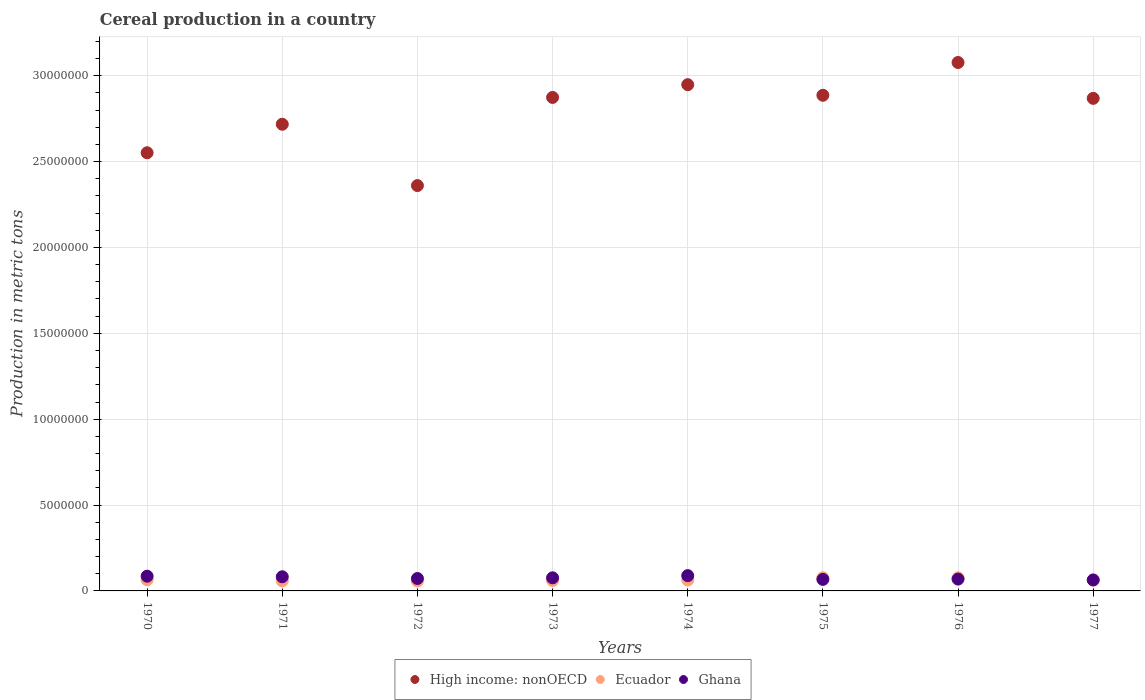What is the total cereal production in Ghana in 1976?
Keep it short and to the point. 6.89e+05. Across all years, what is the maximum total cereal production in High income: nonOECD?
Your response must be concise. 3.08e+07. Across all years, what is the minimum total cereal production in Ecuador?
Keep it short and to the point. 5.77e+05. In which year was the total cereal production in Ghana maximum?
Provide a succinct answer. 1974. What is the total total cereal production in High income: nonOECD in the graph?
Your response must be concise. 2.23e+08. What is the difference between the total cereal production in Ghana in 1971 and that in 1973?
Make the answer very short. 5.90e+04. What is the difference between the total cereal production in Ghana in 1973 and the total cereal production in Ecuador in 1976?
Give a very brief answer. 77. What is the average total cereal production in Ecuador per year?
Your answer should be compact. 6.53e+05. In the year 1975, what is the difference between the total cereal production in High income: nonOECD and total cereal production in Ecuador?
Provide a succinct answer. 2.81e+07. In how many years, is the total cereal production in Ecuador greater than 12000000 metric tons?
Make the answer very short. 0. What is the ratio of the total cereal production in Ecuador in 1972 to that in 1977?
Offer a terse response. 0.92. Is the total cereal production in High income: nonOECD in 1974 less than that in 1976?
Make the answer very short. Yes. What is the difference between the highest and the second highest total cereal production in High income: nonOECD?
Provide a succinct answer. 1.29e+06. What is the difference between the highest and the lowest total cereal production in High income: nonOECD?
Your response must be concise. 7.17e+06. In how many years, is the total cereal production in Ghana greater than the average total cereal production in Ghana taken over all years?
Offer a terse response. 4. Is the sum of the total cereal production in Ghana in 1970 and 1976 greater than the maximum total cereal production in High income: nonOECD across all years?
Your answer should be compact. No. Is the total cereal production in Ghana strictly greater than the total cereal production in High income: nonOECD over the years?
Make the answer very short. No. Are the values on the major ticks of Y-axis written in scientific E-notation?
Your response must be concise. No. Does the graph contain any zero values?
Your answer should be compact. No. Does the graph contain grids?
Offer a very short reply. Yes. Where does the legend appear in the graph?
Offer a terse response. Bottom center. How many legend labels are there?
Offer a very short reply. 3. What is the title of the graph?
Your answer should be very brief. Cereal production in a country. Does "Malawi" appear as one of the legend labels in the graph?
Provide a succinct answer. No. What is the label or title of the Y-axis?
Your response must be concise. Production in metric tons. What is the Production in metric tons of High income: nonOECD in 1970?
Your answer should be very brief. 2.55e+07. What is the Production in metric tons of Ecuador in 1970?
Provide a short and direct response. 6.51e+05. What is the Production in metric tons of Ghana in 1970?
Offer a terse response. 8.58e+05. What is the Production in metric tons in High income: nonOECD in 1971?
Offer a very short reply. 2.72e+07. What is the Production in metric tons in Ecuador in 1971?
Offer a terse response. 5.89e+05. What is the Production in metric tons in Ghana in 1971?
Give a very brief answer. 8.23e+05. What is the Production in metric tons of High income: nonOECD in 1972?
Offer a very short reply. 2.36e+07. What is the Production in metric tons of Ecuador in 1972?
Give a very brief answer. 5.77e+05. What is the Production in metric tons in Ghana in 1972?
Make the answer very short. 7.24e+05. What is the Production in metric tons of High income: nonOECD in 1973?
Your answer should be compact. 2.87e+07. What is the Production in metric tons in Ecuador in 1973?
Provide a succinct answer. 6.08e+05. What is the Production in metric tons in Ghana in 1973?
Make the answer very short. 7.64e+05. What is the Production in metric tons in High income: nonOECD in 1974?
Your response must be concise. 2.95e+07. What is the Production in metric tons of Ecuador in 1974?
Provide a succinct answer. 6.36e+05. What is the Production in metric tons of Ghana in 1974?
Offer a terse response. 8.90e+05. What is the Production in metric tons in High income: nonOECD in 1975?
Your answer should be very brief. 2.89e+07. What is the Production in metric tons of Ecuador in 1975?
Provide a short and direct response. 7.67e+05. What is the Production in metric tons in Ghana in 1975?
Your answer should be compact. 6.72e+05. What is the Production in metric tons in High income: nonOECD in 1976?
Your response must be concise. 3.08e+07. What is the Production in metric tons in Ecuador in 1976?
Keep it short and to the point. 7.64e+05. What is the Production in metric tons of Ghana in 1976?
Make the answer very short. 6.89e+05. What is the Production in metric tons in High income: nonOECD in 1977?
Provide a short and direct response. 2.87e+07. What is the Production in metric tons in Ecuador in 1977?
Keep it short and to the point. 6.31e+05. What is the Production in metric tons in Ghana in 1977?
Make the answer very short. 6.39e+05. Across all years, what is the maximum Production in metric tons of High income: nonOECD?
Your answer should be very brief. 3.08e+07. Across all years, what is the maximum Production in metric tons in Ecuador?
Give a very brief answer. 7.67e+05. Across all years, what is the maximum Production in metric tons of Ghana?
Provide a succinct answer. 8.90e+05. Across all years, what is the minimum Production in metric tons of High income: nonOECD?
Your response must be concise. 2.36e+07. Across all years, what is the minimum Production in metric tons in Ecuador?
Make the answer very short. 5.77e+05. Across all years, what is the minimum Production in metric tons in Ghana?
Make the answer very short. 6.39e+05. What is the total Production in metric tons in High income: nonOECD in the graph?
Keep it short and to the point. 2.23e+08. What is the total Production in metric tons of Ecuador in the graph?
Make the answer very short. 5.22e+06. What is the total Production in metric tons of Ghana in the graph?
Make the answer very short. 6.06e+06. What is the difference between the Production in metric tons of High income: nonOECD in 1970 and that in 1971?
Offer a very short reply. -1.66e+06. What is the difference between the Production in metric tons in Ecuador in 1970 and that in 1971?
Your answer should be very brief. 6.20e+04. What is the difference between the Production in metric tons in Ghana in 1970 and that in 1971?
Keep it short and to the point. 3.44e+04. What is the difference between the Production in metric tons of High income: nonOECD in 1970 and that in 1972?
Keep it short and to the point. 1.91e+06. What is the difference between the Production in metric tons of Ecuador in 1970 and that in 1972?
Ensure brevity in your answer.  7.34e+04. What is the difference between the Production in metric tons in Ghana in 1970 and that in 1972?
Keep it short and to the point. 1.34e+05. What is the difference between the Production in metric tons in High income: nonOECD in 1970 and that in 1973?
Offer a terse response. -3.22e+06. What is the difference between the Production in metric tons in Ecuador in 1970 and that in 1973?
Give a very brief answer. 4.26e+04. What is the difference between the Production in metric tons of Ghana in 1970 and that in 1973?
Give a very brief answer. 9.34e+04. What is the difference between the Production in metric tons in High income: nonOECD in 1970 and that in 1974?
Your answer should be very brief. -3.96e+06. What is the difference between the Production in metric tons in Ecuador in 1970 and that in 1974?
Your answer should be very brief. 1.49e+04. What is the difference between the Production in metric tons in Ghana in 1970 and that in 1974?
Your response must be concise. -3.26e+04. What is the difference between the Production in metric tons in High income: nonOECD in 1970 and that in 1975?
Make the answer very short. -3.35e+06. What is the difference between the Production in metric tons in Ecuador in 1970 and that in 1975?
Keep it short and to the point. -1.16e+05. What is the difference between the Production in metric tons in Ghana in 1970 and that in 1975?
Ensure brevity in your answer.  1.86e+05. What is the difference between the Production in metric tons in High income: nonOECD in 1970 and that in 1976?
Give a very brief answer. -5.26e+06. What is the difference between the Production in metric tons of Ecuador in 1970 and that in 1976?
Your answer should be compact. -1.13e+05. What is the difference between the Production in metric tons of Ghana in 1970 and that in 1976?
Ensure brevity in your answer.  1.69e+05. What is the difference between the Production in metric tons of High income: nonOECD in 1970 and that in 1977?
Your answer should be compact. -3.17e+06. What is the difference between the Production in metric tons in Ecuador in 1970 and that in 1977?
Keep it short and to the point. 1.98e+04. What is the difference between the Production in metric tons of Ghana in 1970 and that in 1977?
Your answer should be very brief. 2.18e+05. What is the difference between the Production in metric tons in High income: nonOECD in 1971 and that in 1972?
Provide a short and direct response. 3.57e+06. What is the difference between the Production in metric tons of Ecuador in 1971 and that in 1972?
Make the answer very short. 1.13e+04. What is the difference between the Production in metric tons in Ghana in 1971 and that in 1972?
Keep it short and to the point. 9.96e+04. What is the difference between the Production in metric tons of High income: nonOECD in 1971 and that in 1973?
Keep it short and to the point. -1.56e+06. What is the difference between the Production in metric tons in Ecuador in 1971 and that in 1973?
Ensure brevity in your answer.  -1.94e+04. What is the difference between the Production in metric tons in Ghana in 1971 and that in 1973?
Offer a terse response. 5.90e+04. What is the difference between the Production in metric tons of High income: nonOECD in 1971 and that in 1974?
Your response must be concise. -2.30e+06. What is the difference between the Production in metric tons of Ecuador in 1971 and that in 1974?
Your answer should be very brief. -4.71e+04. What is the difference between the Production in metric tons of Ghana in 1971 and that in 1974?
Keep it short and to the point. -6.70e+04. What is the difference between the Production in metric tons in High income: nonOECD in 1971 and that in 1975?
Your response must be concise. -1.69e+06. What is the difference between the Production in metric tons of Ecuador in 1971 and that in 1975?
Your answer should be compact. -1.78e+05. What is the difference between the Production in metric tons of Ghana in 1971 and that in 1975?
Your response must be concise. 1.52e+05. What is the difference between the Production in metric tons in High income: nonOECD in 1971 and that in 1976?
Provide a short and direct response. -3.60e+06. What is the difference between the Production in metric tons in Ecuador in 1971 and that in 1976?
Your answer should be very brief. -1.75e+05. What is the difference between the Production in metric tons of Ghana in 1971 and that in 1976?
Offer a very short reply. 1.34e+05. What is the difference between the Production in metric tons in High income: nonOECD in 1971 and that in 1977?
Offer a terse response. -1.51e+06. What is the difference between the Production in metric tons of Ecuador in 1971 and that in 1977?
Give a very brief answer. -4.22e+04. What is the difference between the Production in metric tons in Ghana in 1971 and that in 1977?
Offer a terse response. 1.84e+05. What is the difference between the Production in metric tons of High income: nonOECD in 1972 and that in 1973?
Keep it short and to the point. -5.13e+06. What is the difference between the Production in metric tons in Ecuador in 1972 and that in 1973?
Provide a succinct answer. -3.07e+04. What is the difference between the Production in metric tons of Ghana in 1972 and that in 1973?
Ensure brevity in your answer.  -4.06e+04. What is the difference between the Production in metric tons of High income: nonOECD in 1972 and that in 1974?
Your answer should be very brief. -5.87e+06. What is the difference between the Production in metric tons of Ecuador in 1972 and that in 1974?
Your response must be concise. -5.84e+04. What is the difference between the Production in metric tons of Ghana in 1972 and that in 1974?
Your answer should be very brief. -1.67e+05. What is the difference between the Production in metric tons of High income: nonOECD in 1972 and that in 1975?
Your answer should be compact. -5.26e+06. What is the difference between the Production in metric tons of Ecuador in 1972 and that in 1975?
Provide a short and direct response. -1.90e+05. What is the difference between the Production in metric tons in Ghana in 1972 and that in 1975?
Your response must be concise. 5.20e+04. What is the difference between the Production in metric tons of High income: nonOECD in 1972 and that in 1976?
Keep it short and to the point. -7.17e+06. What is the difference between the Production in metric tons in Ecuador in 1972 and that in 1976?
Make the answer very short. -1.87e+05. What is the difference between the Production in metric tons of Ghana in 1972 and that in 1976?
Give a very brief answer. 3.47e+04. What is the difference between the Production in metric tons in High income: nonOECD in 1972 and that in 1977?
Your answer should be compact. -5.08e+06. What is the difference between the Production in metric tons in Ecuador in 1972 and that in 1977?
Your answer should be compact. -5.35e+04. What is the difference between the Production in metric tons of Ghana in 1972 and that in 1977?
Ensure brevity in your answer.  8.45e+04. What is the difference between the Production in metric tons in High income: nonOECD in 1973 and that in 1974?
Your answer should be compact. -7.43e+05. What is the difference between the Production in metric tons in Ecuador in 1973 and that in 1974?
Provide a succinct answer. -2.77e+04. What is the difference between the Production in metric tons in Ghana in 1973 and that in 1974?
Your answer should be compact. -1.26e+05. What is the difference between the Production in metric tons in High income: nonOECD in 1973 and that in 1975?
Your answer should be very brief. -1.25e+05. What is the difference between the Production in metric tons in Ecuador in 1973 and that in 1975?
Provide a succinct answer. -1.59e+05. What is the difference between the Production in metric tons in Ghana in 1973 and that in 1975?
Provide a short and direct response. 9.26e+04. What is the difference between the Production in metric tons in High income: nonOECD in 1973 and that in 1976?
Ensure brevity in your answer.  -2.03e+06. What is the difference between the Production in metric tons in Ecuador in 1973 and that in 1976?
Ensure brevity in your answer.  -1.56e+05. What is the difference between the Production in metric tons in Ghana in 1973 and that in 1976?
Give a very brief answer. 7.53e+04. What is the difference between the Production in metric tons of High income: nonOECD in 1973 and that in 1977?
Keep it short and to the point. 5.30e+04. What is the difference between the Production in metric tons in Ecuador in 1973 and that in 1977?
Provide a succinct answer. -2.28e+04. What is the difference between the Production in metric tons of Ghana in 1973 and that in 1977?
Offer a terse response. 1.25e+05. What is the difference between the Production in metric tons of High income: nonOECD in 1974 and that in 1975?
Ensure brevity in your answer.  6.17e+05. What is the difference between the Production in metric tons in Ecuador in 1974 and that in 1975?
Your answer should be very brief. -1.31e+05. What is the difference between the Production in metric tons in Ghana in 1974 and that in 1975?
Provide a succinct answer. 2.19e+05. What is the difference between the Production in metric tons in High income: nonOECD in 1974 and that in 1976?
Provide a succinct answer. -1.29e+06. What is the difference between the Production in metric tons in Ecuador in 1974 and that in 1976?
Give a very brief answer. -1.28e+05. What is the difference between the Production in metric tons in Ghana in 1974 and that in 1976?
Offer a very short reply. 2.01e+05. What is the difference between the Production in metric tons of High income: nonOECD in 1974 and that in 1977?
Make the answer very short. 7.96e+05. What is the difference between the Production in metric tons of Ecuador in 1974 and that in 1977?
Keep it short and to the point. 4899. What is the difference between the Production in metric tons in Ghana in 1974 and that in 1977?
Offer a terse response. 2.51e+05. What is the difference between the Production in metric tons of High income: nonOECD in 1975 and that in 1976?
Offer a terse response. -1.91e+06. What is the difference between the Production in metric tons of Ecuador in 1975 and that in 1976?
Your answer should be very brief. 2927. What is the difference between the Production in metric tons of Ghana in 1975 and that in 1976?
Your response must be concise. -1.73e+04. What is the difference between the Production in metric tons in High income: nonOECD in 1975 and that in 1977?
Your response must be concise. 1.78e+05. What is the difference between the Production in metric tons of Ecuador in 1975 and that in 1977?
Provide a succinct answer. 1.36e+05. What is the difference between the Production in metric tons of Ghana in 1975 and that in 1977?
Your answer should be compact. 3.25e+04. What is the difference between the Production in metric tons of High income: nonOECD in 1976 and that in 1977?
Make the answer very short. 2.09e+06. What is the difference between the Production in metric tons in Ecuador in 1976 and that in 1977?
Your response must be concise. 1.33e+05. What is the difference between the Production in metric tons of Ghana in 1976 and that in 1977?
Make the answer very short. 4.98e+04. What is the difference between the Production in metric tons of High income: nonOECD in 1970 and the Production in metric tons of Ecuador in 1971?
Keep it short and to the point. 2.49e+07. What is the difference between the Production in metric tons of High income: nonOECD in 1970 and the Production in metric tons of Ghana in 1971?
Keep it short and to the point. 2.47e+07. What is the difference between the Production in metric tons in Ecuador in 1970 and the Production in metric tons in Ghana in 1971?
Keep it short and to the point. -1.72e+05. What is the difference between the Production in metric tons of High income: nonOECD in 1970 and the Production in metric tons of Ecuador in 1972?
Ensure brevity in your answer.  2.49e+07. What is the difference between the Production in metric tons of High income: nonOECD in 1970 and the Production in metric tons of Ghana in 1972?
Your response must be concise. 2.48e+07. What is the difference between the Production in metric tons of Ecuador in 1970 and the Production in metric tons of Ghana in 1972?
Offer a very short reply. -7.27e+04. What is the difference between the Production in metric tons of High income: nonOECD in 1970 and the Production in metric tons of Ecuador in 1973?
Provide a short and direct response. 2.49e+07. What is the difference between the Production in metric tons of High income: nonOECD in 1970 and the Production in metric tons of Ghana in 1973?
Offer a terse response. 2.47e+07. What is the difference between the Production in metric tons in Ecuador in 1970 and the Production in metric tons in Ghana in 1973?
Offer a very short reply. -1.13e+05. What is the difference between the Production in metric tons in High income: nonOECD in 1970 and the Production in metric tons in Ecuador in 1974?
Your answer should be compact. 2.49e+07. What is the difference between the Production in metric tons in High income: nonOECD in 1970 and the Production in metric tons in Ghana in 1974?
Your response must be concise. 2.46e+07. What is the difference between the Production in metric tons of Ecuador in 1970 and the Production in metric tons of Ghana in 1974?
Your answer should be very brief. -2.39e+05. What is the difference between the Production in metric tons in High income: nonOECD in 1970 and the Production in metric tons in Ecuador in 1975?
Give a very brief answer. 2.47e+07. What is the difference between the Production in metric tons in High income: nonOECD in 1970 and the Production in metric tons in Ghana in 1975?
Your answer should be compact. 2.48e+07. What is the difference between the Production in metric tons in Ecuador in 1970 and the Production in metric tons in Ghana in 1975?
Keep it short and to the point. -2.07e+04. What is the difference between the Production in metric tons in High income: nonOECD in 1970 and the Production in metric tons in Ecuador in 1976?
Your answer should be compact. 2.47e+07. What is the difference between the Production in metric tons in High income: nonOECD in 1970 and the Production in metric tons in Ghana in 1976?
Offer a terse response. 2.48e+07. What is the difference between the Production in metric tons of Ecuador in 1970 and the Production in metric tons of Ghana in 1976?
Offer a very short reply. -3.80e+04. What is the difference between the Production in metric tons of High income: nonOECD in 1970 and the Production in metric tons of Ecuador in 1977?
Your response must be concise. 2.49e+07. What is the difference between the Production in metric tons of High income: nonOECD in 1970 and the Production in metric tons of Ghana in 1977?
Your response must be concise. 2.49e+07. What is the difference between the Production in metric tons in Ecuador in 1970 and the Production in metric tons in Ghana in 1977?
Keep it short and to the point. 1.18e+04. What is the difference between the Production in metric tons of High income: nonOECD in 1971 and the Production in metric tons of Ecuador in 1972?
Make the answer very short. 2.66e+07. What is the difference between the Production in metric tons of High income: nonOECD in 1971 and the Production in metric tons of Ghana in 1972?
Give a very brief answer. 2.65e+07. What is the difference between the Production in metric tons in Ecuador in 1971 and the Production in metric tons in Ghana in 1972?
Give a very brief answer. -1.35e+05. What is the difference between the Production in metric tons of High income: nonOECD in 1971 and the Production in metric tons of Ecuador in 1973?
Ensure brevity in your answer.  2.66e+07. What is the difference between the Production in metric tons of High income: nonOECD in 1971 and the Production in metric tons of Ghana in 1973?
Provide a succinct answer. 2.64e+07. What is the difference between the Production in metric tons of Ecuador in 1971 and the Production in metric tons of Ghana in 1973?
Keep it short and to the point. -1.75e+05. What is the difference between the Production in metric tons in High income: nonOECD in 1971 and the Production in metric tons in Ecuador in 1974?
Offer a very short reply. 2.65e+07. What is the difference between the Production in metric tons of High income: nonOECD in 1971 and the Production in metric tons of Ghana in 1974?
Keep it short and to the point. 2.63e+07. What is the difference between the Production in metric tons of Ecuador in 1971 and the Production in metric tons of Ghana in 1974?
Offer a very short reply. -3.01e+05. What is the difference between the Production in metric tons in High income: nonOECD in 1971 and the Production in metric tons in Ecuador in 1975?
Ensure brevity in your answer.  2.64e+07. What is the difference between the Production in metric tons of High income: nonOECD in 1971 and the Production in metric tons of Ghana in 1975?
Provide a succinct answer. 2.65e+07. What is the difference between the Production in metric tons of Ecuador in 1971 and the Production in metric tons of Ghana in 1975?
Your answer should be very brief. -8.27e+04. What is the difference between the Production in metric tons of High income: nonOECD in 1971 and the Production in metric tons of Ecuador in 1976?
Provide a short and direct response. 2.64e+07. What is the difference between the Production in metric tons of High income: nonOECD in 1971 and the Production in metric tons of Ghana in 1976?
Your answer should be compact. 2.65e+07. What is the difference between the Production in metric tons in Ecuador in 1971 and the Production in metric tons in Ghana in 1976?
Keep it short and to the point. -1.00e+05. What is the difference between the Production in metric tons in High income: nonOECD in 1971 and the Production in metric tons in Ecuador in 1977?
Make the answer very short. 2.65e+07. What is the difference between the Production in metric tons of High income: nonOECD in 1971 and the Production in metric tons of Ghana in 1977?
Keep it short and to the point. 2.65e+07. What is the difference between the Production in metric tons in Ecuador in 1971 and the Production in metric tons in Ghana in 1977?
Offer a very short reply. -5.02e+04. What is the difference between the Production in metric tons in High income: nonOECD in 1972 and the Production in metric tons in Ecuador in 1973?
Give a very brief answer. 2.30e+07. What is the difference between the Production in metric tons of High income: nonOECD in 1972 and the Production in metric tons of Ghana in 1973?
Ensure brevity in your answer.  2.28e+07. What is the difference between the Production in metric tons of Ecuador in 1972 and the Production in metric tons of Ghana in 1973?
Ensure brevity in your answer.  -1.87e+05. What is the difference between the Production in metric tons in High income: nonOECD in 1972 and the Production in metric tons in Ecuador in 1974?
Your answer should be compact. 2.30e+07. What is the difference between the Production in metric tons in High income: nonOECD in 1972 and the Production in metric tons in Ghana in 1974?
Offer a very short reply. 2.27e+07. What is the difference between the Production in metric tons of Ecuador in 1972 and the Production in metric tons of Ghana in 1974?
Provide a short and direct response. -3.13e+05. What is the difference between the Production in metric tons of High income: nonOECD in 1972 and the Production in metric tons of Ecuador in 1975?
Give a very brief answer. 2.28e+07. What is the difference between the Production in metric tons in High income: nonOECD in 1972 and the Production in metric tons in Ghana in 1975?
Your answer should be very brief. 2.29e+07. What is the difference between the Production in metric tons in Ecuador in 1972 and the Production in metric tons in Ghana in 1975?
Provide a short and direct response. -9.41e+04. What is the difference between the Production in metric tons of High income: nonOECD in 1972 and the Production in metric tons of Ecuador in 1976?
Ensure brevity in your answer.  2.28e+07. What is the difference between the Production in metric tons in High income: nonOECD in 1972 and the Production in metric tons in Ghana in 1976?
Offer a terse response. 2.29e+07. What is the difference between the Production in metric tons in Ecuador in 1972 and the Production in metric tons in Ghana in 1976?
Your response must be concise. -1.11e+05. What is the difference between the Production in metric tons of High income: nonOECD in 1972 and the Production in metric tons of Ecuador in 1977?
Offer a terse response. 2.30e+07. What is the difference between the Production in metric tons of High income: nonOECD in 1972 and the Production in metric tons of Ghana in 1977?
Give a very brief answer. 2.30e+07. What is the difference between the Production in metric tons of Ecuador in 1972 and the Production in metric tons of Ghana in 1977?
Provide a succinct answer. -6.16e+04. What is the difference between the Production in metric tons of High income: nonOECD in 1973 and the Production in metric tons of Ecuador in 1974?
Make the answer very short. 2.81e+07. What is the difference between the Production in metric tons of High income: nonOECD in 1973 and the Production in metric tons of Ghana in 1974?
Make the answer very short. 2.78e+07. What is the difference between the Production in metric tons of Ecuador in 1973 and the Production in metric tons of Ghana in 1974?
Offer a very short reply. -2.82e+05. What is the difference between the Production in metric tons of High income: nonOECD in 1973 and the Production in metric tons of Ecuador in 1975?
Your answer should be compact. 2.80e+07. What is the difference between the Production in metric tons of High income: nonOECD in 1973 and the Production in metric tons of Ghana in 1975?
Keep it short and to the point. 2.81e+07. What is the difference between the Production in metric tons in Ecuador in 1973 and the Production in metric tons in Ghana in 1975?
Your answer should be very brief. -6.33e+04. What is the difference between the Production in metric tons of High income: nonOECD in 1973 and the Production in metric tons of Ecuador in 1976?
Keep it short and to the point. 2.80e+07. What is the difference between the Production in metric tons in High income: nonOECD in 1973 and the Production in metric tons in Ghana in 1976?
Make the answer very short. 2.80e+07. What is the difference between the Production in metric tons in Ecuador in 1973 and the Production in metric tons in Ghana in 1976?
Keep it short and to the point. -8.06e+04. What is the difference between the Production in metric tons of High income: nonOECD in 1973 and the Production in metric tons of Ecuador in 1977?
Your answer should be compact. 2.81e+07. What is the difference between the Production in metric tons of High income: nonOECD in 1973 and the Production in metric tons of Ghana in 1977?
Ensure brevity in your answer.  2.81e+07. What is the difference between the Production in metric tons of Ecuador in 1973 and the Production in metric tons of Ghana in 1977?
Keep it short and to the point. -3.08e+04. What is the difference between the Production in metric tons of High income: nonOECD in 1974 and the Production in metric tons of Ecuador in 1975?
Make the answer very short. 2.87e+07. What is the difference between the Production in metric tons in High income: nonOECD in 1974 and the Production in metric tons in Ghana in 1975?
Offer a terse response. 2.88e+07. What is the difference between the Production in metric tons in Ecuador in 1974 and the Production in metric tons in Ghana in 1975?
Your answer should be compact. -3.57e+04. What is the difference between the Production in metric tons of High income: nonOECD in 1974 and the Production in metric tons of Ecuador in 1976?
Your answer should be compact. 2.87e+07. What is the difference between the Production in metric tons of High income: nonOECD in 1974 and the Production in metric tons of Ghana in 1976?
Give a very brief answer. 2.88e+07. What is the difference between the Production in metric tons of Ecuador in 1974 and the Production in metric tons of Ghana in 1976?
Ensure brevity in your answer.  -5.30e+04. What is the difference between the Production in metric tons in High income: nonOECD in 1974 and the Production in metric tons in Ecuador in 1977?
Your answer should be very brief. 2.88e+07. What is the difference between the Production in metric tons of High income: nonOECD in 1974 and the Production in metric tons of Ghana in 1977?
Your answer should be very brief. 2.88e+07. What is the difference between the Production in metric tons in Ecuador in 1974 and the Production in metric tons in Ghana in 1977?
Give a very brief answer. -3153. What is the difference between the Production in metric tons in High income: nonOECD in 1975 and the Production in metric tons in Ecuador in 1976?
Offer a terse response. 2.81e+07. What is the difference between the Production in metric tons in High income: nonOECD in 1975 and the Production in metric tons in Ghana in 1976?
Provide a short and direct response. 2.82e+07. What is the difference between the Production in metric tons of Ecuador in 1975 and the Production in metric tons of Ghana in 1976?
Make the answer very short. 7.82e+04. What is the difference between the Production in metric tons of High income: nonOECD in 1975 and the Production in metric tons of Ecuador in 1977?
Ensure brevity in your answer.  2.82e+07. What is the difference between the Production in metric tons of High income: nonOECD in 1975 and the Production in metric tons of Ghana in 1977?
Keep it short and to the point. 2.82e+07. What is the difference between the Production in metric tons in Ecuador in 1975 and the Production in metric tons in Ghana in 1977?
Ensure brevity in your answer.  1.28e+05. What is the difference between the Production in metric tons in High income: nonOECD in 1976 and the Production in metric tons in Ecuador in 1977?
Make the answer very short. 3.01e+07. What is the difference between the Production in metric tons of High income: nonOECD in 1976 and the Production in metric tons of Ghana in 1977?
Provide a succinct answer. 3.01e+07. What is the difference between the Production in metric tons in Ecuador in 1976 and the Production in metric tons in Ghana in 1977?
Your response must be concise. 1.25e+05. What is the average Production in metric tons of High income: nonOECD per year?
Ensure brevity in your answer.  2.79e+07. What is the average Production in metric tons of Ecuador per year?
Keep it short and to the point. 6.53e+05. What is the average Production in metric tons in Ghana per year?
Offer a terse response. 7.57e+05. In the year 1970, what is the difference between the Production in metric tons in High income: nonOECD and Production in metric tons in Ecuador?
Keep it short and to the point. 2.49e+07. In the year 1970, what is the difference between the Production in metric tons in High income: nonOECD and Production in metric tons in Ghana?
Give a very brief answer. 2.47e+07. In the year 1970, what is the difference between the Production in metric tons in Ecuador and Production in metric tons in Ghana?
Provide a succinct answer. -2.07e+05. In the year 1971, what is the difference between the Production in metric tons of High income: nonOECD and Production in metric tons of Ecuador?
Provide a succinct answer. 2.66e+07. In the year 1971, what is the difference between the Production in metric tons of High income: nonOECD and Production in metric tons of Ghana?
Your response must be concise. 2.64e+07. In the year 1971, what is the difference between the Production in metric tons of Ecuador and Production in metric tons of Ghana?
Your answer should be compact. -2.34e+05. In the year 1972, what is the difference between the Production in metric tons of High income: nonOECD and Production in metric tons of Ecuador?
Ensure brevity in your answer.  2.30e+07. In the year 1972, what is the difference between the Production in metric tons of High income: nonOECD and Production in metric tons of Ghana?
Your answer should be compact. 2.29e+07. In the year 1972, what is the difference between the Production in metric tons in Ecuador and Production in metric tons in Ghana?
Provide a short and direct response. -1.46e+05. In the year 1973, what is the difference between the Production in metric tons in High income: nonOECD and Production in metric tons in Ecuador?
Offer a terse response. 2.81e+07. In the year 1973, what is the difference between the Production in metric tons in High income: nonOECD and Production in metric tons in Ghana?
Offer a terse response. 2.80e+07. In the year 1973, what is the difference between the Production in metric tons in Ecuador and Production in metric tons in Ghana?
Offer a very short reply. -1.56e+05. In the year 1974, what is the difference between the Production in metric tons in High income: nonOECD and Production in metric tons in Ecuador?
Give a very brief answer. 2.88e+07. In the year 1974, what is the difference between the Production in metric tons of High income: nonOECD and Production in metric tons of Ghana?
Make the answer very short. 2.86e+07. In the year 1974, what is the difference between the Production in metric tons of Ecuador and Production in metric tons of Ghana?
Keep it short and to the point. -2.54e+05. In the year 1975, what is the difference between the Production in metric tons in High income: nonOECD and Production in metric tons in Ecuador?
Offer a very short reply. 2.81e+07. In the year 1975, what is the difference between the Production in metric tons in High income: nonOECD and Production in metric tons in Ghana?
Provide a succinct answer. 2.82e+07. In the year 1975, what is the difference between the Production in metric tons in Ecuador and Production in metric tons in Ghana?
Provide a succinct answer. 9.54e+04. In the year 1976, what is the difference between the Production in metric tons in High income: nonOECD and Production in metric tons in Ecuador?
Give a very brief answer. 3.00e+07. In the year 1976, what is the difference between the Production in metric tons of High income: nonOECD and Production in metric tons of Ghana?
Your answer should be very brief. 3.01e+07. In the year 1976, what is the difference between the Production in metric tons in Ecuador and Production in metric tons in Ghana?
Provide a short and direct response. 7.52e+04. In the year 1977, what is the difference between the Production in metric tons in High income: nonOECD and Production in metric tons in Ecuador?
Keep it short and to the point. 2.81e+07. In the year 1977, what is the difference between the Production in metric tons of High income: nonOECD and Production in metric tons of Ghana?
Your response must be concise. 2.80e+07. In the year 1977, what is the difference between the Production in metric tons in Ecuador and Production in metric tons in Ghana?
Provide a short and direct response. -8052. What is the ratio of the Production in metric tons of High income: nonOECD in 1970 to that in 1971?
Your answer should be compact. 0.94. What is the ratio of the Production in metric tons in Ecuador in 1970 to that in 1971?
Your response must be concise. 1.11. What is the ratio of the Production in metric tons of Ghana in 1970 to that in 1971?
Keep it short and to the point. 1.04. What is the ratio of the Production in metric tons of High income: nonOECD in 1970 to that in 1972?
Keep it short and to the point. 1.08. What is the ratio of the Production in metric tons of Ecuador in 1970 to that in 1972?
Ensure brevity in your answer.  1.13. What is the ratio of the Production in metric tons in Ghana in 1970 to that in 1972?
Give a very brief answer. 1.19. What is the ratio of the Production in metric tons in High income: nonOECD in 1970 to that in 1973?
Your answer should be very brief. 0.89. What is the ratio of the Production in metric tons in Ecuador in 1970 to that in 1973?
Your answer should be compact. 1.07. What is the ratio of the Production in metric tons of Ghana in 1970 to that in 1973?
Make the answer very short. 1.12. What is the ratio of the Production in metric tons of High income: nonOECD in 1970 to that in 1974?
Your answer should be very brief. 0.87. What is the ratio of the Production in metric tons of Ecuador in 1970 to that in 1974?
Ensure brevity in your answer.  1.02. What is the ratio of the Production in metric tons in Ghana in 1970 to that in 1974?
Keep it short and to the point. 0.96. What is the ratio of the Production in metric tons of High income: nonOECD in 1970 to that in 1975?
Offer a very short reply. 0.88. What is the ratio of the Production in metric tons of Ecuador in 1970 to that in 1975?
Offer a terse response. 0.85. What is the ratio of the Production in metric tons in Ghana in 1970 to that in 1975?
Your answer should be very brief. 1.28. What is the ratio of the Production in metric tons in High income: nonOECD in 1970 to that in 1976?
Provide a succinct answer. 0.83. What is the ratio of the Production in metric tons of Ecuador in 1970 to that in 1976?
Give a very brief answer. 0.85. What is the ratio of the Production in metric tons of Ghana in 1970 to that in 1976?
Ensure brevity in your answer.  1.24. What is the ratio of the Production in metric tons in High income: nonOECD in 1970 to that in 1977?
Keep it short and to the point. 0.89. What is the ratio of the Production in metric tons of Ecuador in 1970 to that in 1977?
Offer a very short reply. 1.03. What is the ratio of the Production in metric tons of Ghana in 1970 to that in 1977?
Your answer should be very brief. 1.34. What is the ratio of the Production in metric tons of High income: nonOECD in 1971 to that in 1972?
Give a very brief answer. 1.15. What is the ratio of the Production in metric tons of Ecuador in 1971 to that in 1972?
Give a very brief answer. 1.02. What is the ratio of the Production in metric tons in Ghana in 1971 to that in 1972?
Provide a short and direct response. 1.14. What is the ratio of the Production in metric tons in High income: nonOECD in 1971 to that in 1973?
Give a very brief answer. 0.95. What is the ratio of the Production in metric tons in Ecuador in 1971 to that in 1973?
Provide a short and direct response. 0.97. What is the ratio of the Production in metric tons of Ghana in 1971 to that in 1973?
Your answer should be very brief. 1.08. What is the ratio of the Production in metric tons of High income: nonOECD in 1971 to that in 1974?
Provide a succinct answer. 0.92. What is the ratio of the Production in metric tons in Ecuador in 1971 to that in 1974?
Offer a terse response. 0.93. What is the ratio of the Production in metric tons of Ghana in 1971 to that in 1974?
Give a very brief answer. 0.92. What is the ratio of the Production in metric tons of High income: nonOECD in 1971 to that in 1975?
Your answer should be very brief. 0.94. What is the ratio of the Production in metric tons of Ecuador in 1971 to that in 1975?
Ensure brevity in your answer.  0.77. What is the ratio of the Production in metric tons of Ghana in 1971 to that in 1975?
Provide a succinct answer. 1.23. What is the ratio of the Production in metric tons of High income: nonOECD in 1971 to that in 1976?
Ensure brevity in your answer.  0.88. What is the ratio of the Production in metric tons in Ecuador in 1971 to that in 1976?
Provide a short and direct response. 0.77. What is the ratio of the Production in metric tons of Ghana in 1971 to that in 1976?
Your answer should be very brief. 1.2. What is the ratio of the Production in metric tons in High income: nonOECD in 1971 to that in 1977?
Ensure brevity in your answer.  0.95. What is the ratio of the Production in metric tons in Ecuador in 1971 to that in 1977?
Make the answer very short. 0.93. What is the ratio of the Production in metric tons in Ghana in 1971 to that in 1977?
Your response must be concise. 1.29. What is the ratio of the Production in metric tons in High income: nonOECD in 1972 to that in 1973?
Provide a short and direct response. 0.82. What is the ratio of the Production in metric tons of Ecuador in 1972 to that in 1973?
Make the answer very short. 0.95. What is the ratio of the Production in metric tons in Ghana in 1972 to that in 1973?
Make the answer very short. 0.95. What is the ratio of the Production in metric tons in High income: nonOECD in 1972 to that in 1974?
Your answer should be compact. 0.8. What is the ratio of the Production in metric tons of Ecuador in 1972 to that in 1974?
Provide a succinct answer. 0.91. What is the ratio of the Production in metric tons of Ghana in 1972 to that in 1974?
Provide a short and direct response. 0.81. What is the ratio of the Production in metric tons of High income: nonOECD in 1972 to that in 1975?
Provide a short and direct response. 0.82. What is the ratio of the Production in metric tons of Ecuador in 1972 to that in 1975?
Your answer should be very brief. 0.75. What is the ratio of the Production in metric tons of Ghana in 1972 to that in 1975?
Make the answer very short. 1.08. What is the ratio of the Production in metric tons in High income: nonOECD in 1972 to that in 1976?
Give a very brief answer. 0.77. What is the ratio of the Production in metric tons in Ecuador in 1972 to that in 1976?
Provide a succinct answer. 0.76. What is the ratio of the Production in metric tons of Ghana in 1972 to that in 1976?
Keep it short and to the point. 1.05. What is the ratio of the Production in metric tons in High income: nonOECD in 1972 to that in 1977?
Ensure brevity in your answer.  0.82. What is the ratio of the Production in metric tons in Ecuador in 1972 to that in 1977?
Make the answer very short. 0.92. What is the ratio of the Production in metric tons of Ghana in 1972 to that in 1977?
Give a very brief answer. 1.13. What is the ratio of the Production in metric tons of High income: nonOECD in 1973 to that in 1974?
Ensure brevity in your answer.  0.97. What is the ratio of the Production in metric tons of Ecuador in 1973 to that in 1974?
Your answer should be compact. 0.96. What is the ratio of the Production in metric tons in Ghana in 1973 to that in 1974?
Keep it short and to the point. 0.86. What is the ratio of the Production in metric tons of High income: nonOECD in 1973 to that in 1975?
Provide a succinct answer. 1. What is the ratio of the Production in metric tons of Ecuador in 1973 to that in 1975?
Offer a terse response. 0.79. What is the ratio of the Production in metric tons of Ghana in 1973 to that in 1975?
Offer a very short reply. 1.14. What is the ratio of the Production in metric tons of High income: nonOECD in 1973 to that in 1976?
Offer a terse response. 0.93. What is the ratio of the Production in metric tons of Ecuador in 1973 to that in 1976?
Provide a short and direct response. 0.8. What is the ratio of the Production in metric tons in Ghana in 1973 to that in 1976?
Provide a succinct answer. 1.11. What is the ratio of the Production in metric tons in High income: nonOECD in 1973 to that in 1977?
Give a very brief answer. 1. What is the ratio of the Production in metric tons in Ecuador in 1973 to that in 1977?
Your answer should be compact. 0.96. What is the ratio of the Production in metric tons of Ghana in 1973 to that in 1977?
Provide a short and direct response. 1.2. What is the ratio of the Production in metric tons in High income: nonOECD in 1974 to that in 1975?
Keep it short and to the point. 1.02. What is the ratio of the Production in metric tons of Ecuador in 1974 to that in 1975?
Give a very brief answer. 0.83. What is the ratio of the Production in metric tons in Ghana in 1974 to that in 1975?
Ensure brevity in your answer.  1.33. What is the ratio of the Production in metric tons in High income: nonOECD in 1974 to that in 1976?
Ensure brevity in your answer.  0.96. What is the ratio of the Production in metric tons of Ecuador in 1974 to that in 1976?
Offer a very short reply. 0.83. What is the ratio of the Production in metric tons of Ghana in 1974 to that in 1976?
Your response must be concise. 1.29. What is the ratio of the Production in metric tons in High income: nonOECD in 1974 to that in 1977?
Offer a very short reply. 1.03. What is the ratio of the Production in metric tons of Ghana in 1974 to that in 1977?
Offer a very short reply. 1.39. What is the ratio of the Production in metric tons of High income: nonOECD in 1975 to that in 1976?
Your response must be concise. 0.94. What is the ratio of the Production in metric tons in Ecuador in 1975 to that in 1976?
Provide a short and direct response. 1. What is the ratio of the Production in metric tons of Ghana in 1975 to that in 1976?
Your answer should be compact. 0.97. What is the ratio of the Production in metric tons in Ecuador in 1975 to that in 1977?
Provide a short and direct response. 1.22. What is the ratio of the Production in metric tons in Ghana in 1975 to that in 1977?
Offer a very short reply. 1.05. What is the ratio of the Production in metric tons of High income: nonOECD in 1976 to that in 1977?
Ensure brevity in your answer.  1.07. What is the ratio of the Production in metric tons of Ecuador in 1976 to that in 1977?
Offer a terse response. 1.21. What is the ratio of the Production in metric tons in Ghana in 1976 to that in 1977?
Your answer should be compact. 1.08. What is the difference between the highest and the second highest Production in metric tons of High income: nonOECD?
Your answer should be very brief. 1.29e+06. What is the difference between the highest and the second highest Production in metric tons in Ecuador?
Ensure brevity in your answer.  2927. What is the difference between the highest and the second highest Production in metric tons in Ghana?
Your answer should be compact. 3.26e+04. What is the difference between the highest and the lowest Production in metric tons in High income: nonOECD?
Your response must be concise. 7.17e+06. What is the difference between the highest and the lowest Production in metric tons of Ecuador?
Provide a succinct answer. 1.90e+05. What is the difference between the highest and the lowest Production in metric tons of Ghana?
Provide a succinct answer. 2.51e+05. 